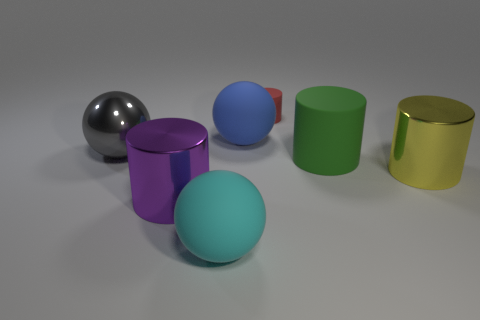Do the big blue matte object and the shiny object to the left of the large purple metal cylinder have the same shape?
Offer a terse response. Yes. What number of things are cylinders that are behind the gray thing or big red cylinders?
Your answer should be very brief. 1. Are the cyan sphere and the purple object that is in front of the red rubber cylinder made of the same material?
Provide a short and direct response. No. There is a rubber thing left of the large thing behind the gray metallic object; what shape is it?
Keep it short and to the point. Sphere. Do the tiny cylinder and the large metal object to the right of the red rubber cylinder have the same color?
Provide a succinct answer. No. Is there any other thing that has the same material as the yellow object?
Your answer should be very brief. Yes. The yellow object has what shape?
Your answer should be compact. Cylinder. What is the size of the object behind the matte sphere behind the cyan object?
Give a very brief answer. Small. Is the number of tiny matte objects that are to the right of the yellow shiny thing the same as the number of big green rubber things that are in front of the tiny red rubber cylinder?
Your answer should be compact. No. There is a big cylinder that is on the left side of the yellow object and behind the purple metal cylinder; what is its material?
Offer a very short reply. Rubber. 